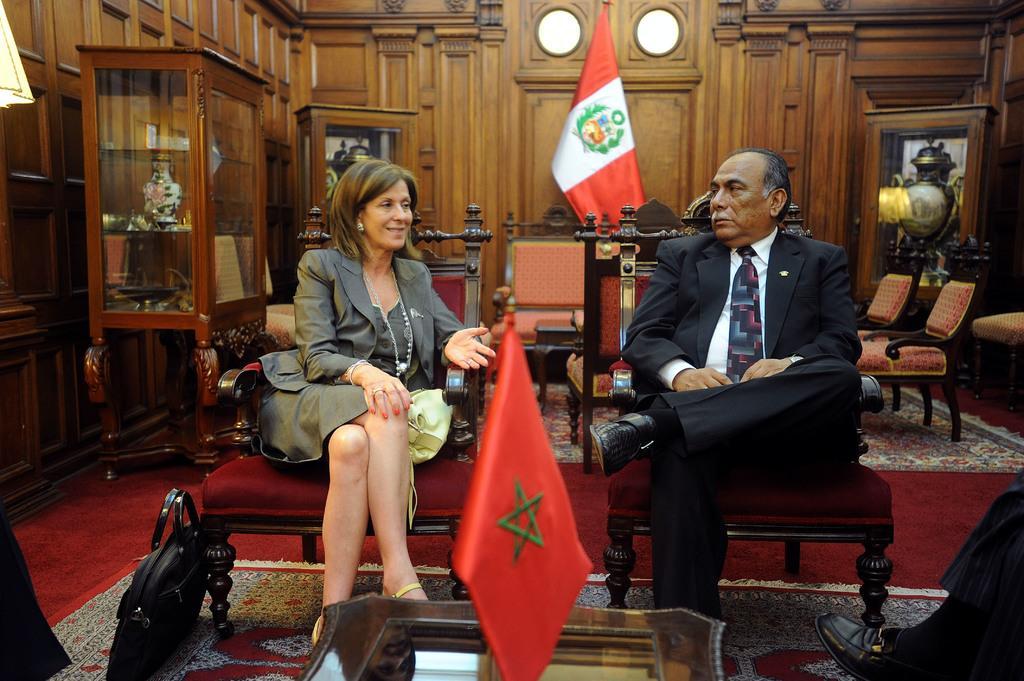In one or two sentences, can you explain what this image depicts? In this image, there are a few people sitting on chairs. We can see the ground with some objects. We can also see the sofa and a few chairs. We can see the wooden wall. We can see an object with some glass at the bottom. We can also see some flags and some objects in glass cupboards. We can also see an object in the top left corner. We can see an object in the bottom left corner. 